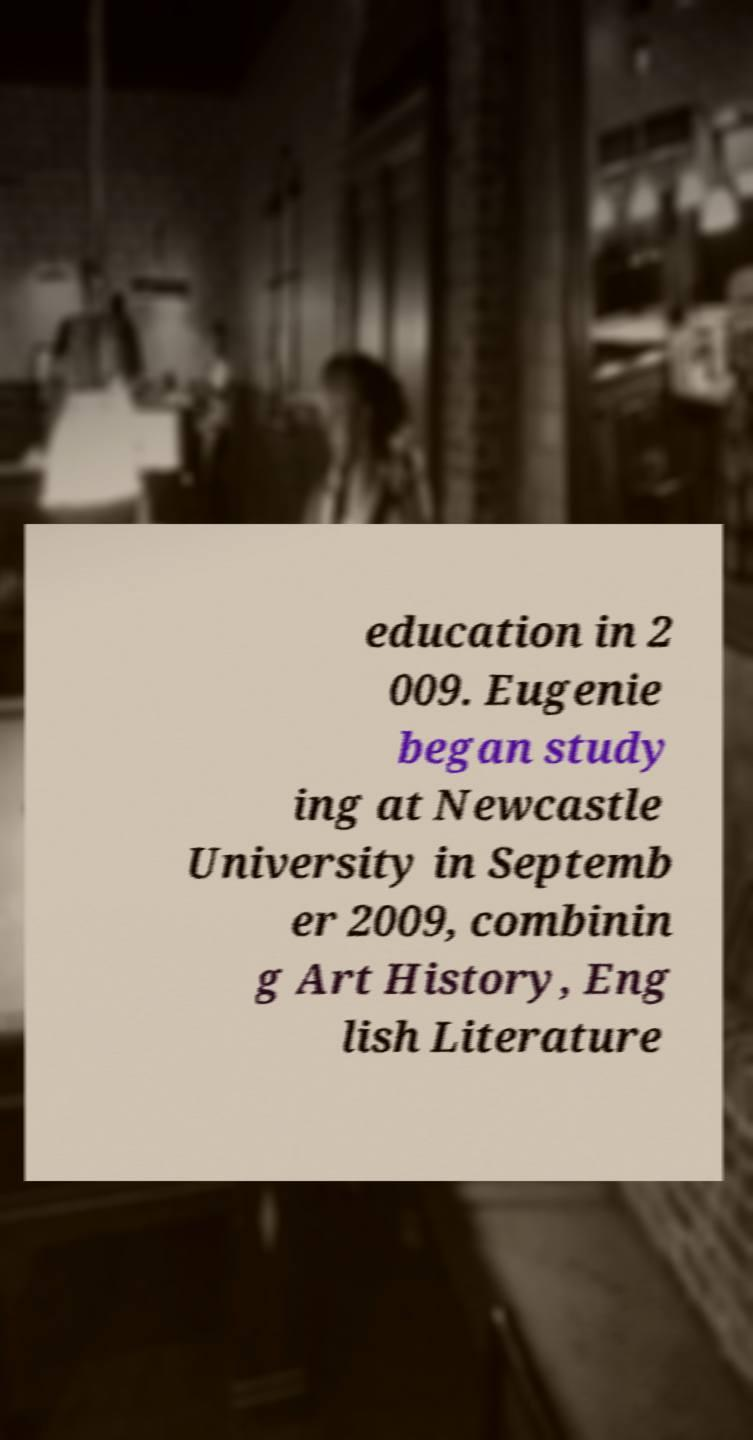Please identify and transcribe the text found in this image. education in 2 009. Eugenie began study ing at Newcastle University in Septemb er 2009, combinin g Art History, Eng lish Literature 